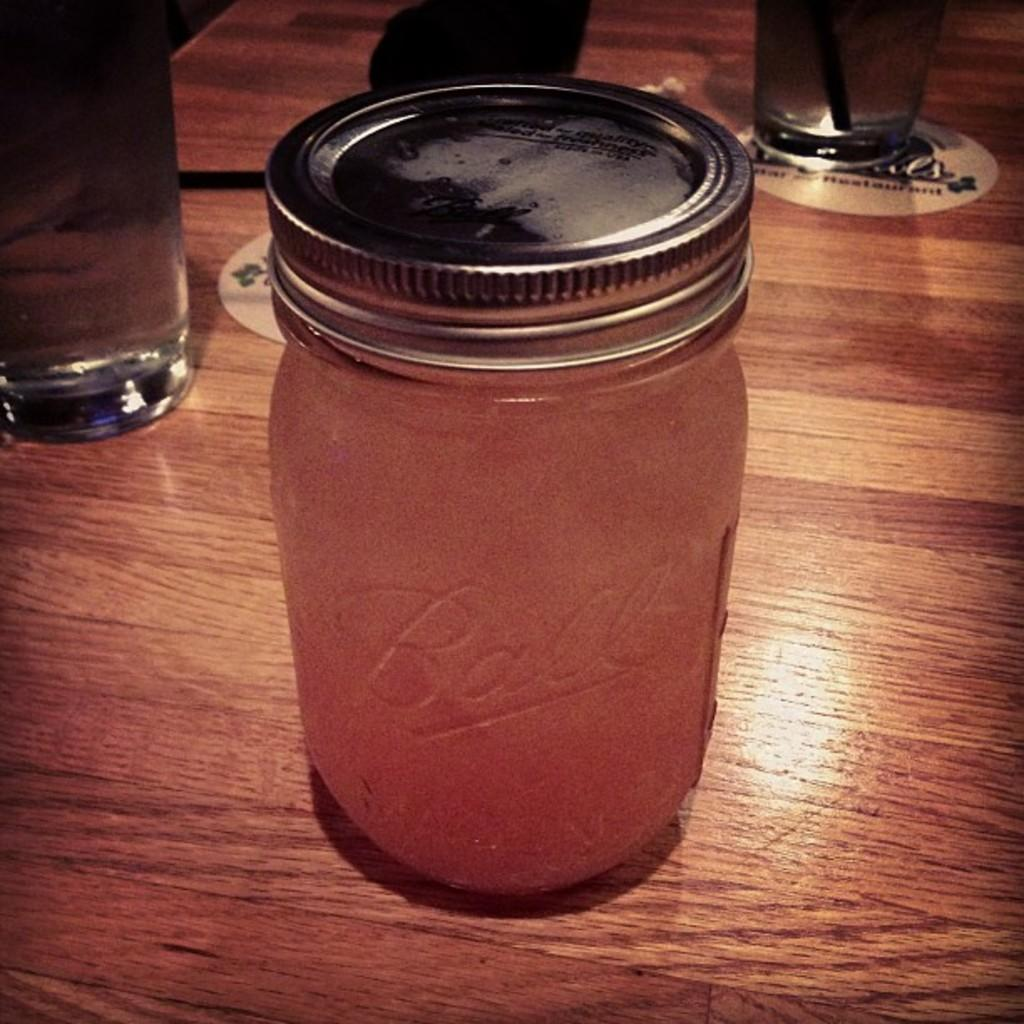What type of surface is visible in the image? There is a wooden surface in the image. What is placed on the wooden surface? There is a glass bottle with a lid on the wooden surface. Are there any other objects visible behind the bottle? Yes, there are glasses behind the bottle. What type of farm animals can be seen grazing on the wooden surface in the image? There are no farm animals present in the image; it features a glass bottle with a lid on a wooden surface. 